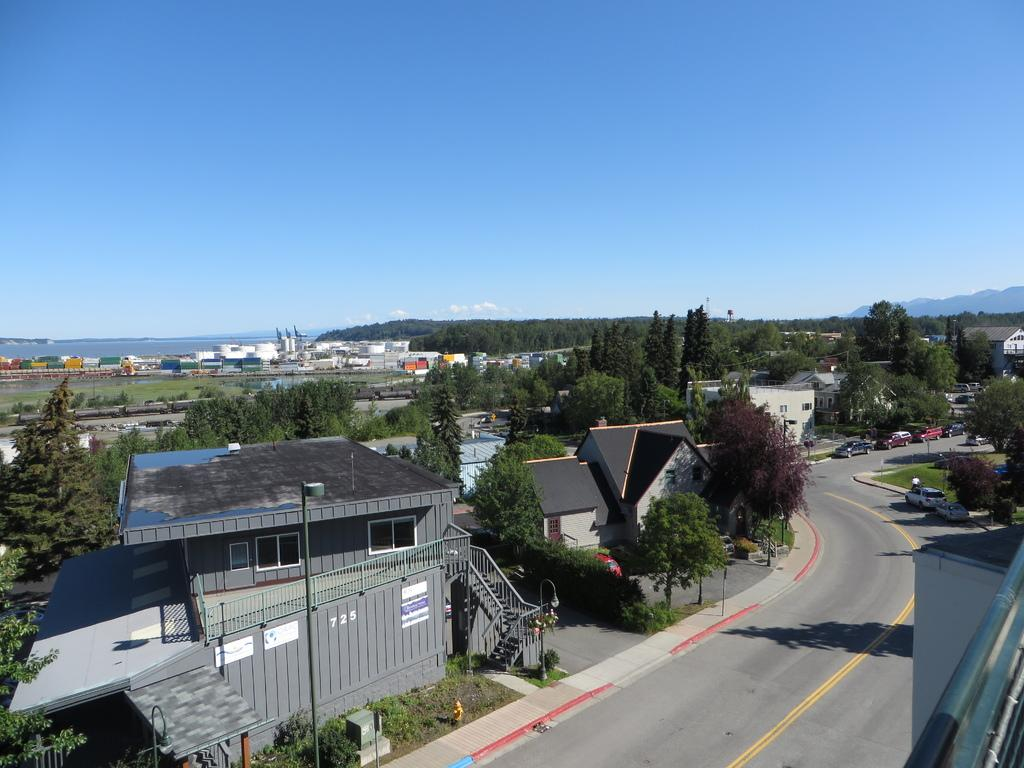What is happening on the road in the image? There are vehicles on the road in the image. What can be seen in the distance behind the vehicles? There are buildings and trees in the background of the image. What is visible in the sky in the background of the image? There are clouds in the sky in the background of the image. What type of pickle is being used as a prop in the image? There is no pickle present in the image. Can you tell me if the dad is driving one of the vehicles in the image? There is no information about a dad or anyone driving in the image. 